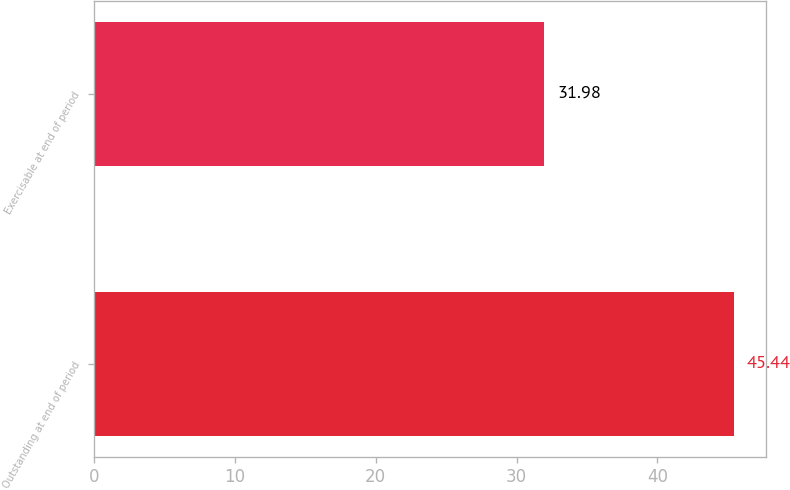Convert chart. <chart><loc_0><loc_0><loc_500><loc_500><bar_chart><fcel>Outstanding at end of period<fcel>Exercisable at end of period<nl><fcel>45.44<fcel>31.98<nl></chart> 